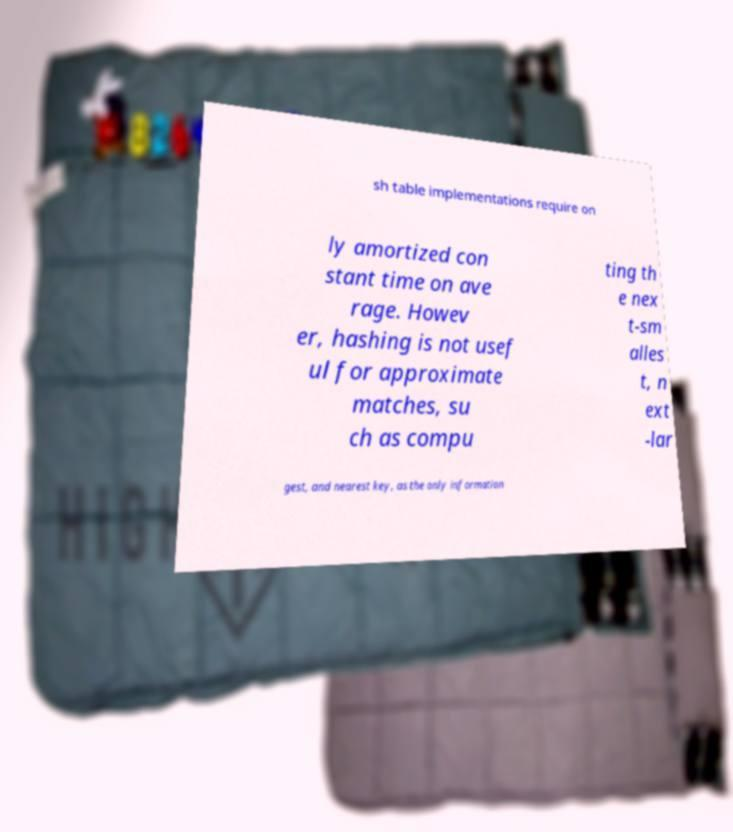Please read and relay the text visible in this image. What does it say? sh table implementations require on ly amortized con stant time on ave rage. Howev er, hashing is not usef ul for approximate matches, su ch as compu ting th e nex t-sm alles t, n ext -lar gest, and nearest key, as the only information 